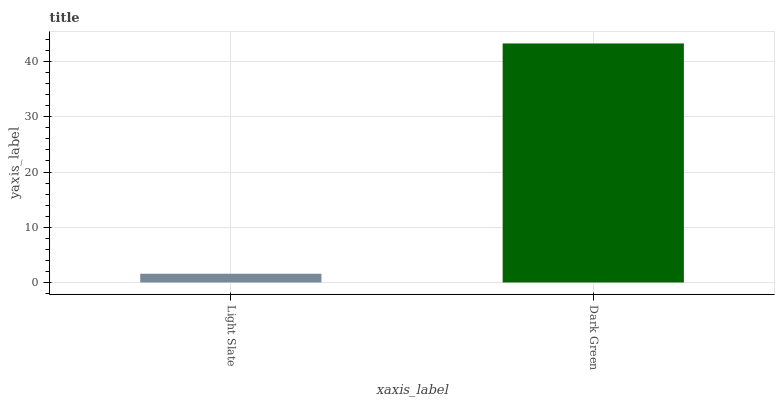Is Light Slate the minimum?
Answer yes or no. Yes. Is Dark Green the maximum?
Answer yes or no. Yes. Is Dark Green the minimum?
Answer yes or no. No. Is Dark Green greater than Light Slate?
Answer yes or no. Yes. Is Light Slate less than Dark Green?
Answer yes or no. Yes. Is Light Slate greater than Dark Green?
Answer yes or no. No. Is Dark Green less than Light Slate?
Answer yes or no. No. Is Dark Green the high median?
Answer yes or no. Yes. Is Light Slate the low median?
Answer yes or no. Yes. Is Light Slate the high median?
Answer yes or no. No. Is Dark Green the low median?
Answer yes or no. No. 